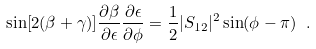<formula> <loc_0><loc_0><loc_500><loc_500>\sin [ 2 ( \beta + \gamma ) ] \frac { \partial \beta } { \partial \epsilon } \frac { \partial \epsilon } { \partial \phi } = \frac { 1 } { 2 } | S _ { 1 2 } | ^ { 2 } \sin ( \phi - \pi ) \ .</formula> 